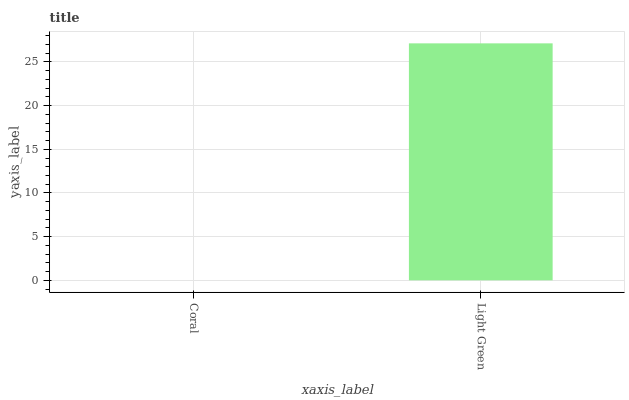Is Coral the minimum?
Answer yes or no. Yes. Is Light Green the maximum?
Answer yes or no. Yes. Is Light Green the minimum?
Answer yes or no. No. Is Light Green greater than Coral?
Answer yes or no. Yes. Is Coral less than Light Green?
Answer yes or no. Yes. Is Coral greater than Light Green?
Answer yes or no. No. Is Light Green less than Coral?
Answer yes or no. No. Is Light Green the high median?
Answer yes or no. Yes. Is Coral the low median?
Answer yes or no. Yes. Is Coral the high median?
Answer yes or no. No. Is Light Green the low median?
Answer yes or no. No. 